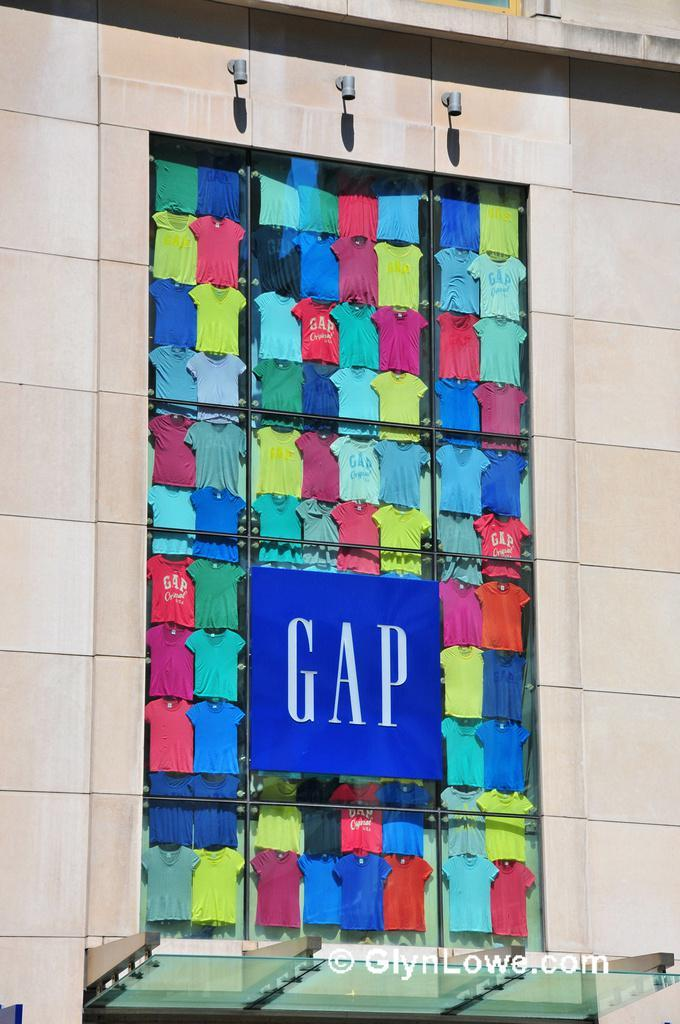What type of structure is present in the image? There is a building in the image. What feature can be seen on the building? The building has windows. What can be seen through one of the windows? There is a group of t-shirts visible through a window. What sign is present in the image? There is a name board in the image. What type of illumination is present in the image? There are lights in the image. What text is visible at the bottom of the image? There is some text at the bottom of the image. What type of cherries are being served in the image? There are no cherries present in the image. What type of food is being prepared in the image? There is no food preparation visible in the image. 